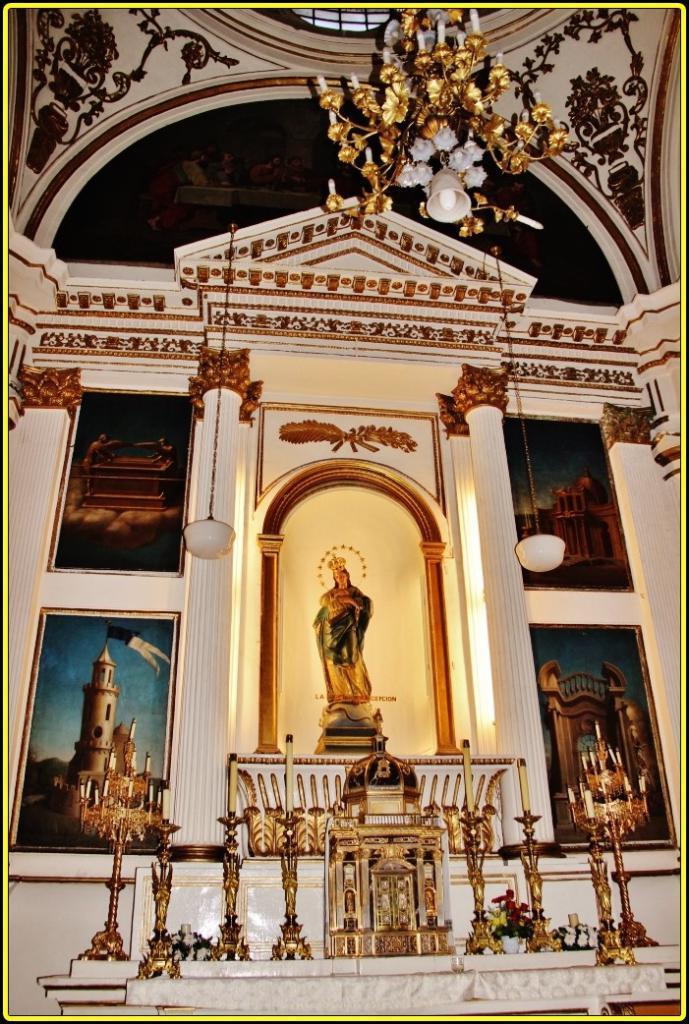Please provide a concise description of this image. This picture is an inside view of a building. In the center of the image we can see statue, boards, wall. At the bottom of the image we can see some stands, candles. At the top of the image we can see chandelier, roof. 